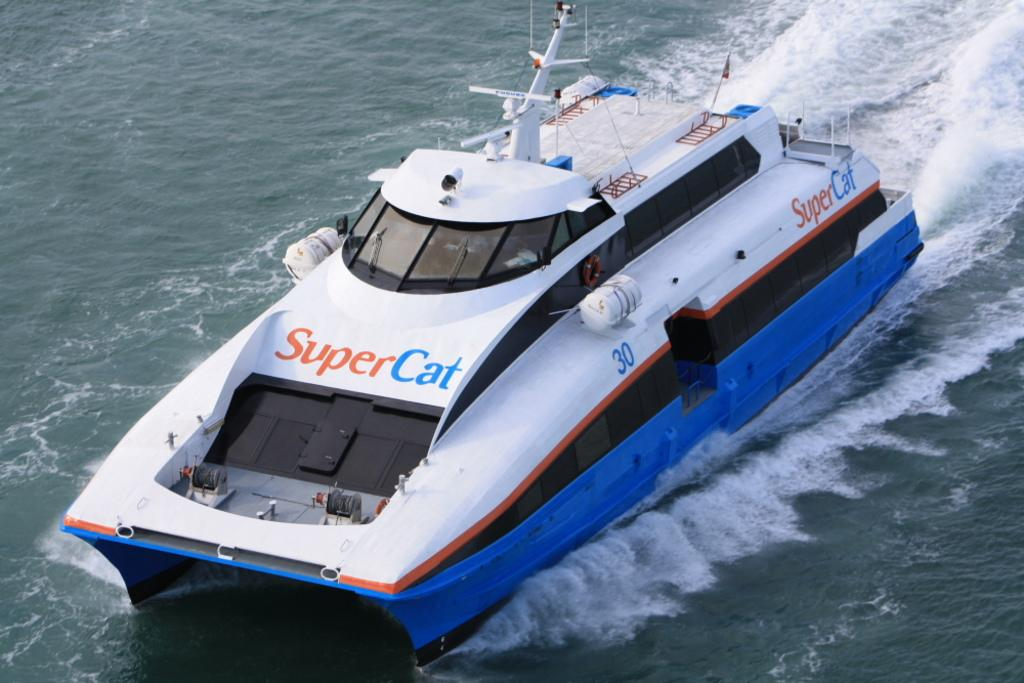<image>
Render a clear and concise summary of the photo. a boat on the ocean sailing called the super cat 